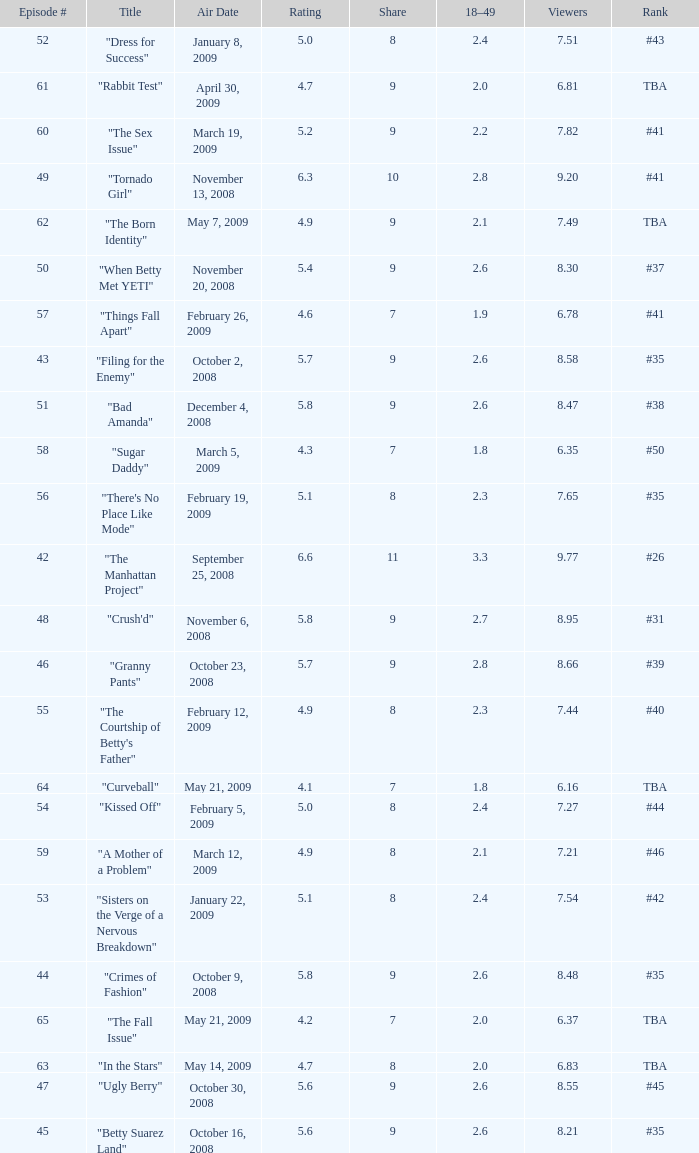What is the lowest Viewers that has an Episode #higher than 58 with a title of "curveball" less than 4.1 rating? None. 